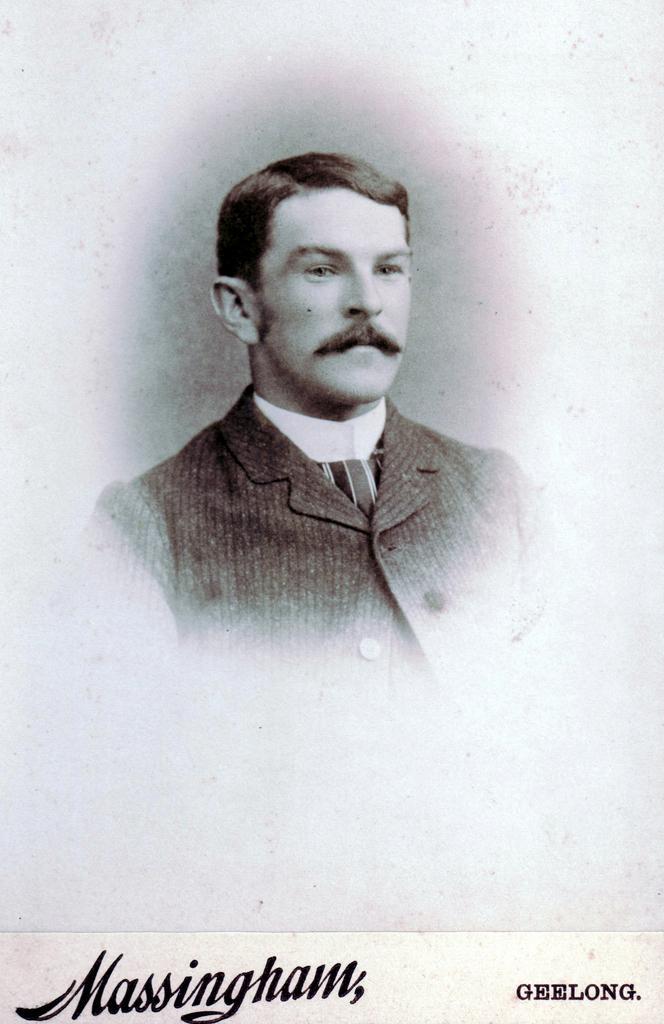Could you give a brief overview of what you see in this image? This looks like an edited image. I can see the man. These are the letters on the image. 